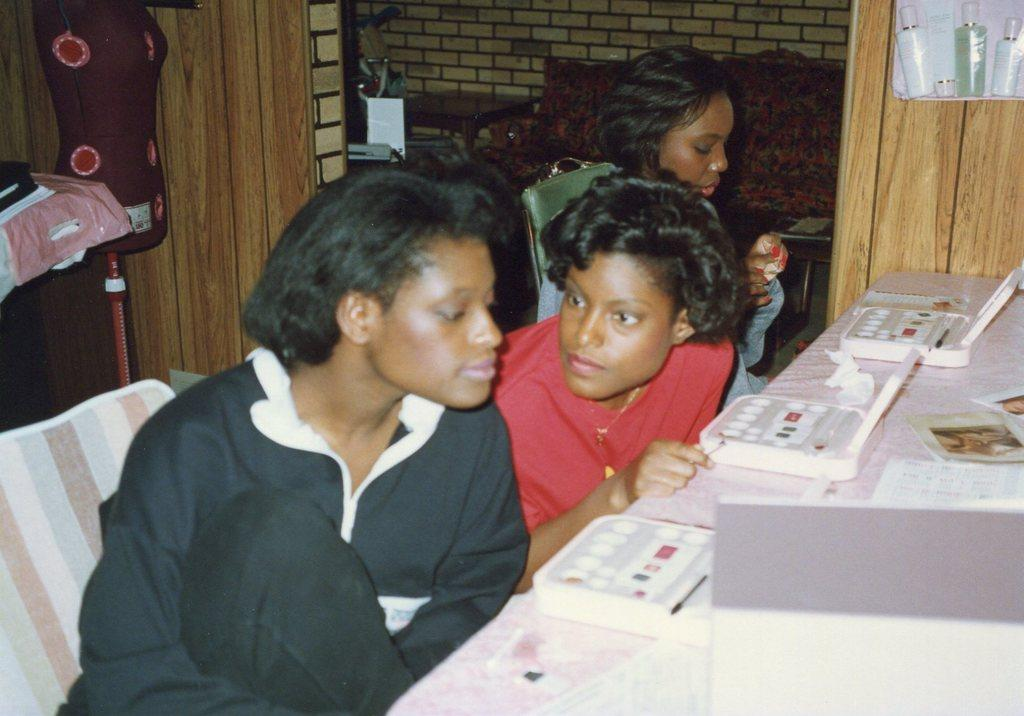How many girls are present in the image? There are three girls in the image. What are the girls doing in the image? The girls are sitting on chairs. What is the primary piece of furniture in the image? There is a table in the image. What can be found on the table? There are objects on the table. What can be seen in the background of the image? There is a brick wall in the background of the image. Can you see a fly sitting on the table in the image? There is no fly present on the table in the image. Are there any frogs joining the girls in the image? There are no frogs present in the image. 